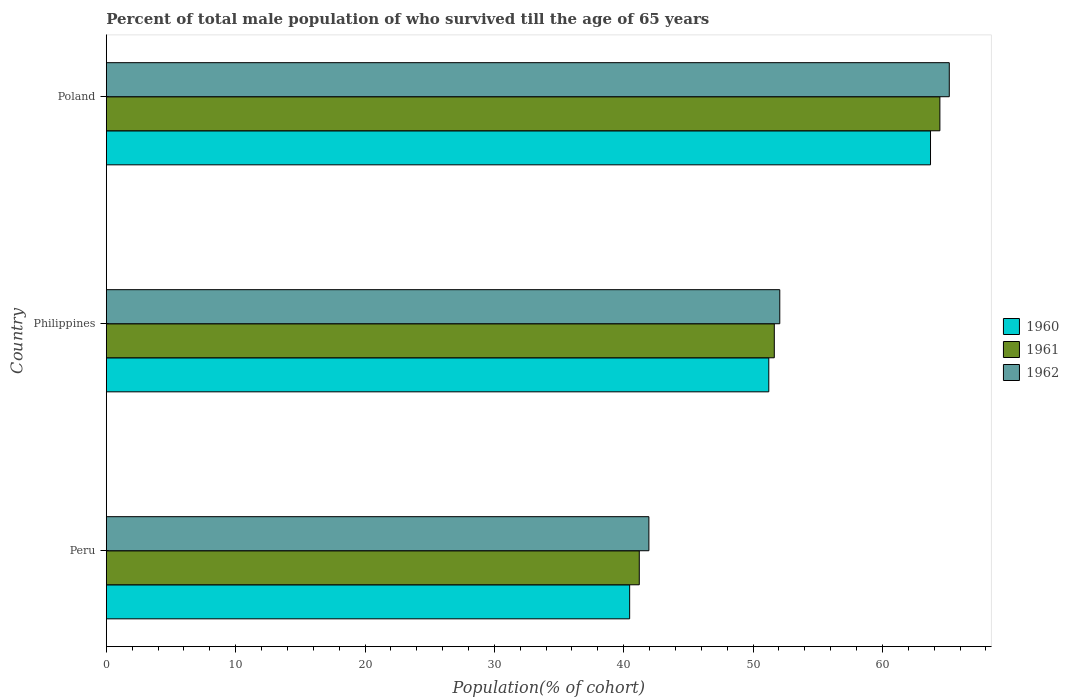How many different coloured bars are there?
Offer a terse response. 3. How many groups of bars are there?
Offer a very short reply. 3. How many bars are there on the 2nd tick from the top?
Your response must be concise. 3. How many bars are there on the 1st tick from the bottom?
Make the answer very short. 3. What is the label of the 2nd group of bars from the top?
Keep it short and to the point. Philippines. In how many cases, is the number of bars for a given country not equal to the number of legend labels?
Provide a succinct answer. 0. What is the percentage of total male population who survived till the age of 65 years in 1962 in Philippines?
Provide a short and direct response. 52.07. Across all countries, what is the maximum percentage of total male population who survived till the age of 65 years in 1960?
Keep it short and to the point. 63.72. Across all countries, what is the minimum percentage of total male population who survived till the age of 65 years in 1962?
Ensure brevity in your answer.  41.95. What is the total percentage of total male population who survived till the age of 65 years in 1962 in the graph?
Provide a succinct answer. 159.18. What is the difference between the percentage of total male population who survived till the age of 65 years in 1961 in Peru and that in Poland?
Your response must be concise. -23.24. What is the difference between the percentage of total male population who survived till the age of 65 years in 1960 in Poland and the percentage of total male population who survived till the age of 65 years in 1961 in Philippines?
Ensure brevity in your answer.  12.08. What is the average percentage of total male population who survived till the age of 65 years in 1960 per country?
Keep it short and to the point. 51.8. What is the difference between the percentage of total male population who survived till the age of 65 years in 1961 and percentage of total male population who survived till the age of 65 years in 1962 in Philippines?
Ensure brevity in your answer.  -0.42. In how many countries, is the percentage of total male population who survived till the age of 65 years in 1962 greater than 10 %?
Your answer should be very brief. 3. What is the ratio of the percentage of total male population who survived till the age of 65 years in 1962 in Peru to that in Philippines?
Your answer should be compact. 0.81. Is the difference between the percentage of total male population who survived till the age of 65 years in 1961 in Peru and Poland greater than the difference between the percentage of total male population who survived till the age of 65 years in 1962 in Peru and Poland?
Your answer should be very brief. No. What is the difference between the highest and the second highest percentage of total male population who survived till the age of 65 years in 1960?
Your answer should be very brief. 12.5. What is the difference between the highest and the lowest percentage of total male population who survived till the age of 65 years in 1961?
Ensure brevity in your answer.  23.24. Is the sum of the percentage of total male population who survived till the age of 65 years in 1962 in Peru and Poland greater than the maximum percentage of total male population who survived till the age of 65 years in 1961 across all countries?
Keep it short and to the point. Yes. What does the 3rd bar from the top in Peru represents?
Ensure brevity in your answer.  1960. How many bars are there?
Provide a succinct answer. 9. Are all the bars in the graph horizontal?
Offer a terse response. Yes. How many countries are there in the graph?
Make the answer very short. 3. Does the graph contain any zero values?
Your response must be concise. No. Does the graph contain grids?
Ensure brevity in your answer.  No. How are the legend labels stacked?
Ensure brevity in your answer.  Vertical. What is the title of the graph?
Offer a very short reply. Percent of total male population of who survived till the age of 65 years. Does "2000" appear as one of the legend labels in the graph?
Offer a very short reply. No. What is the label or title of the X-axis?
Offer a terse response. Population(% of cohort). What is the Population(% of cohort) of 1960 in Peru?
Make the answer very short. 40.46. What is the Population(% of cohort) of 1961 in Peru?
Offer a very short reply. 41.2. What is the Population(% of cohort) of 1962 in Peru?
Provide a succinct answer. 41.95. What is the Population(% of cohort) of 1960 in Philippines?
Ensure brevity in your answer.  51.22. What is the Population(% of cohort) of 1961 in Philippines?
Provide a succinct answer. 51.64. What is the Population(% of cohort) of 1962 in Philippines?
Ensure brevity in your answer.  52.07. What is the Population(% of cohort) of 1960 in Poland?
Keep it short and to the point. 63.72. What is the Population(% of cohort) in 1961 in Poland?
Your answer should be very brief. 64.44. What is the Population(% of cohort) of 1962 in Poland?
Your answer should be very brief. 65.17. Across all countries, what is the maximum Population(% of cohort) in 1960?
Provide a short and direct response. 63.72. Across all countries, what is the maximum Population(% of cohort) of 1961?
Offer a terse response. 64.44. Across all countries, what is the maximum Population(% of cohort) of 1962?
Ensure brevity in your answer.  65.17. Across all countries, what is the minimum Population(% of cohort) of 1960?
Provide a short and direct response. 40.46. Across all countries, what is the minimum Population(% of cohort) of 1961?
Ensure brevity in your answer.  41.2. Across all countries, what is the minimum Population(% of cohort) of 1962?
Provide a short and direct response. 41.95. What is the total Population(% of cohort) of 1960 in the graph?
Make the answer very short. 155.39. What is the total Population(% of cohort) of 1961 in the graph?
Ensure brevity in your answer.  157.29. What is the total Population(% of cohort) of 1962 in the graph?
Provide a succinct answer. 159.18. What is the difference between the Population(% of cohort) of 1960 in Peru and that in Philippines?
Your answer should be very brief. -10.76. What is the difference between the Population(% of cohort) of 1961 in Peru and that in Philippines?
Your answer should be very brief. -10.44. What is the difference between the Population(% of cohort) of 1962 in Peru and that in Philippines?
Keep it short and to the point. -10.12. What is the difference between the Population(% of cohort) of 1960 in Peru and that in Poland?
Give a very brief answer. -23.26. What is the difference between the Population(% of cohort) in 1961 in Peru and that in Poland?
Offer a very short reply. -23.24. What is the difference between the Population(% of cohort) of 1962 in Peru and that in Poland?
Make the answer very short. -23.22. What is the difference between the Population(% of cohort) of 1960 in Philippines and that in Poland?
Offer a very short reply. -12.5. What is the difference between the Population(% of cohort) of 1961 in Philippines and that in Poland?
Make the answer very short. -12.8. What is the difference between the Population(% of cohort) in 1962 in Philippines and that in Poland?
Provide a succinct answer. -13.1. What is the difference between the Population(% of cohort) of 1960 in Peru and the Population(% of cohort) of 1961 in Philippines?
Your answer should be very brief. -11.18. What is the difference between the Population(% of cohort) in 1960 in Peru and the Population(% of cohort) in 1962 in Philippines?
Your response must be concise. -11.61. What is the difference between the Population(% of cohort) of 1961 in Peru and the Population(% of cohort) of 1962 in Philippines?
Make the answer very short. -10.86. What is the difference between the Population(% of cohort) of 1960 in Peru and the Population(% of cohort) of 1961 in Poland?
Your answer should be compact. -23.99. What is the difference between the Population(% of cohort) of 1960 in Peru and the Population(% of cohort) of 1962 in Poland?
Your answer should be compact. -24.71. What is the difference between the Population(% of cohort) of 1961 in Peru and the Population(% of cohort) of 1962 in Poland?
Offer a very short reply. -23.97. What is the difference between the Population(% of cohort) in 1960 in Philippines and the Population(% of cohort) in 1961 in Poland?
Your answer should be very brief. -13.23. What is the difference between the Population(% of cohort) of 1960 in Philippines and the Population(% of cohort) of 1962 in Poland?
Offer a terse response. -13.95. What is the difference between the Population(% of cohort) of 1961 in Philippines and the Population(% of cohort) of 1962 in Poland?
Your answer should be compact. -13.53. What is the average Population(% of cohort) in 1960 per country?
Offer a very short reply. 51.8. What is the average Population(% of cohort) in 1961 per country?
Provide a short and direct response. 52.43. What is the average Population(% of cohort) of 1962 per country?
Offer a very short reply. 53.06. What is the difference between the Population(% of cohort) of 1960 and Population(% of cohort) of 1961 in Peru?
Your answer should be compact. -0.74. What is the difference between the Population(% of cohort) in 1960 and Population(% of cohort) in 1962 in Peru?
Make the answer very short. -1.49. What is the difference between the Population(% of cohort) in 1961 and Population(% of cohort) in 1962 in Peru?
Make the answer very short. -0.74. What is the difference between the Population(% of cohort) in 1960 and Population(% of cohort) in 1961 in Philippines?
Make the answer very short. -0.42. What is the difference between the Population(% of cohort) in 1960 and Population(% of cohort) in 1962 in Philippines?
Keep it short and to the point. -0.85. What is the difference between the Population(% of cohort) in 1961 and Population(% of cohort) in 1962 in Philippines?
Your answer should be very brief. -0.42. What is the difference between the Population(% of cohort) in 1960 and Population(% of cohort) in 1961 in Poland?
Provide a short and direct response. -0.73. What is the difference between the Population(% of cohort) in 1960 and Population(% of cohort) in 1962 in Poland?
Provide a succinct answer. -1.45. What is the difference between the Population(% of cohort) of 1961 and Population(% of cohort) of 1962 in Poland?
Provide a succinct answer. -0.73. What is the ratio of the Population(% of cohort) of 1960 in Peru to that in Philippines?
Keep it short and to the point. 0.79. What is the ratio of the Population(% of cohort) in 1961 in Peru to that in Philippines?
Give a very brief answer. 0.8. What is the ratio of the Population(% of cohort) of 1962 in Peru to that in Philippines?
Make the answer very short. 0.81. What is the ratio of the Population(% of cohort) in 1960 in Peru to that in Poland?
Provide a succinct answer. 0.64. What is the ratio of the Population(% of cohort) of 1961 in Peru to that in Poland?
Your answer should be very brief. 0.64. What is the ratio of the Population(% of cohort) of 1962 in Peru to that in Poland?
Give a very brief answer. 0.64. What is the ratio of the Population(% of cohort) in 1960 in Philippines to that in Poland?
Your response must be concise. 0.8. What is the ratio of the Population(% of cohort) in 1961 in Philippines to that in Poland?
Provide a short and direct response. 0.8. What is the ratio of the Population(% of cohort) in 1962 in Philippines to that in Poland?
Offer a terse response. 0.8. What is the difference between the highest and the second highest Population(% of cohort) in 1960?
Your answer should be very brief. 12.5. What is the difference between the highest and the second highest Population(% of cohort) in 1961?
Keep it short and to the point. 12.8. What is the difference between the highest and the second highest Population(% of cohort) in 1962?
Make the answer very short. 13.1. What is the difference between the highest and the lowest Population(% of cohort) of 1960?
Keep it short and to the point. 23.26. What is the difference between the highest and the lowest Population(% of cohort) in 1961?
Your answer should be compact. 23.24. What is the difference between the highest and the lowest Population(% of cohort) in 1962?
Give a very brief answer. 23.22. 